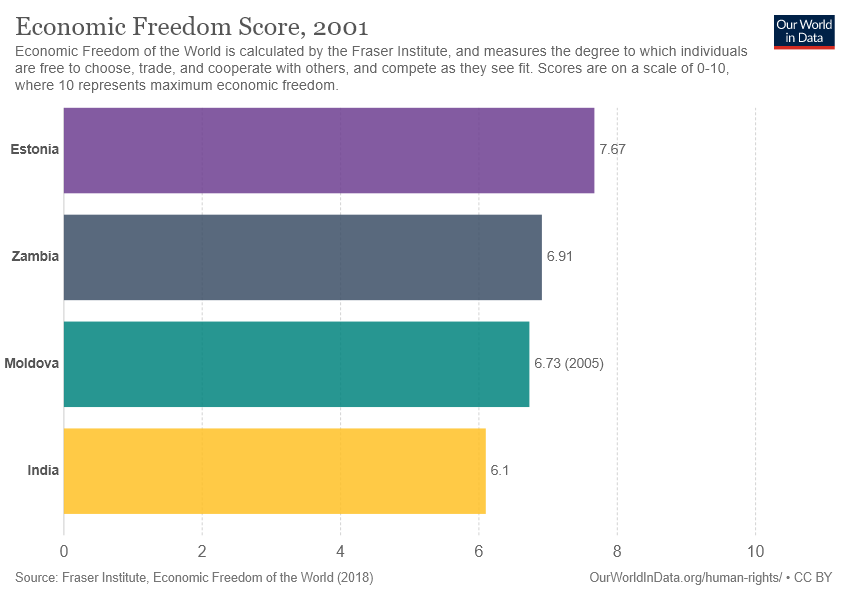Specify some key components in this picture. The yellow bar represents India, which is a country. India and Estonia have a difference in value of 1.57. 